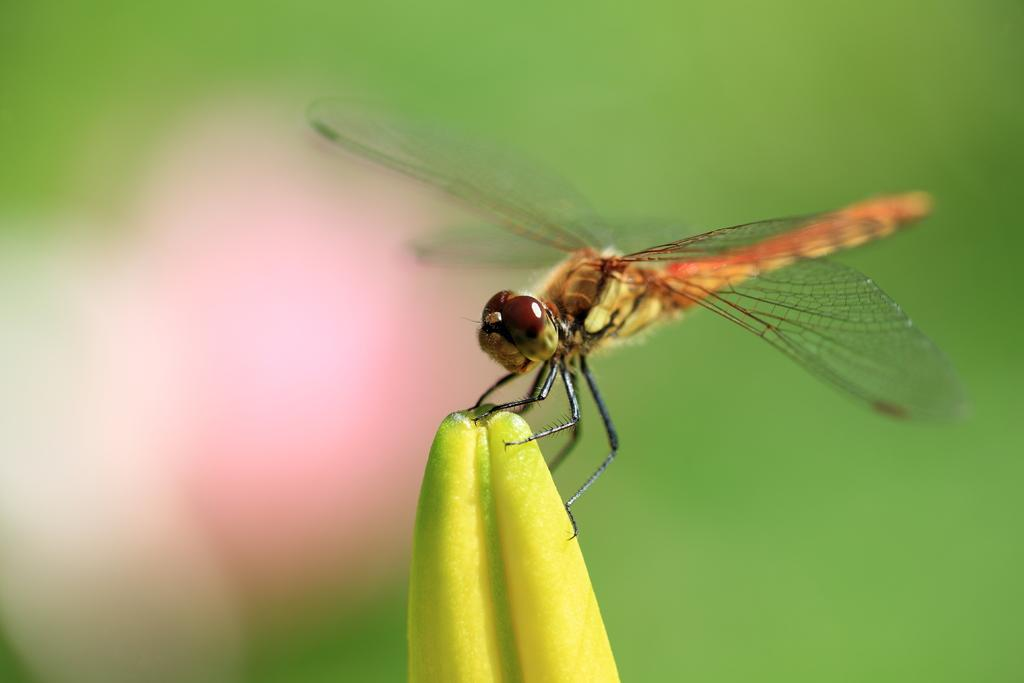What is present in the image? There is an insect in the image. Where is the insect located? The insect is on a flower. Can you describe the background of the image? The background of the image is blurred. What type of sponge is being used to clean the insect in the image? There is no sponge present in the image, nor is the insect being cleaned. 